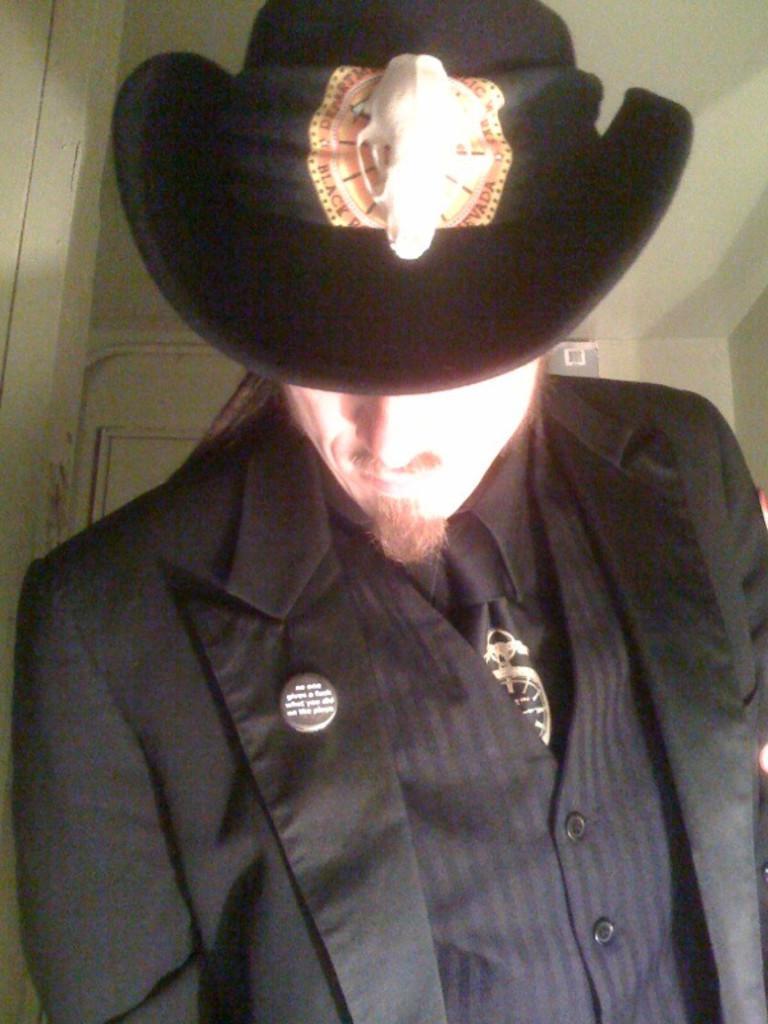In one or two sentences, can you explain what this image depicts? In this picture, we see the man in black shirt and black blazer is wearing a black hat. Behind him, we see a white wall and a white door. This picture is clicked inside the room. 